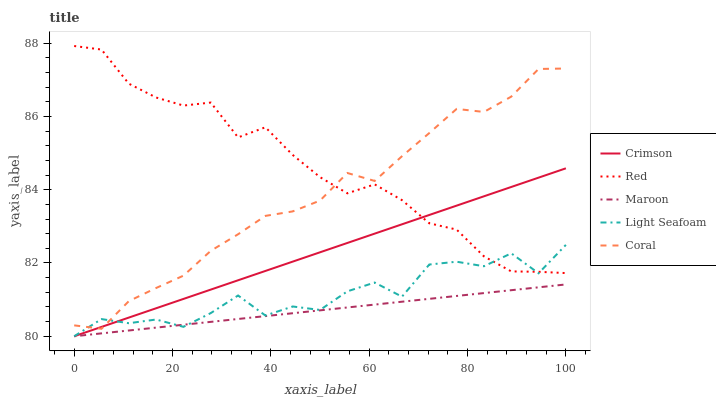Does Maroon have the minimum area under the curve?
Answer yes or no. Yes. Does Red have the maximum area under the curve?
Answer yes or no. Yes. Does Coral have the minimum area under the curve?
Answer yes or no. No. Does Coral have the maximum area under the curve?
Answer yes or no. No. Is Maroon the smoothest?
Answer yes or no. Yes. Is Light Seafoam the roughest?
Answer yes or no. Yes. Is Coral the smoothest?
Answer yes or no. No. Is Coral the roughest?
Answer yes or no. No. Does Crimson have the lowest value?
Answer yes or no. Yes. Does Coral have the lowest value?
Answer yes or no. No. Does Red have the highest value?
Answer yes or no. Yes. Does Coral have the highest value?
Answer yes or no. No. Is Maroon less than Coral?
Answer yes or no. Yes. Is Coral greater than Maroon?
Answer yes or no. Yes. Does Red intersect Crimson?
Answer yes or no. Yes. Is Red less than Crimson?
Answer yes or no. No. Is Red greater than Crimson?
Answer yes or no. No. Does Maroon intersect Coral?
Answer yes or no. No. 